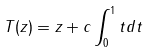<formula> <loc_0><loc_0><loc_500><loc_500>T ( z ) = z + c \int _ { 0 } ^ { 1 } t d t</formula> 